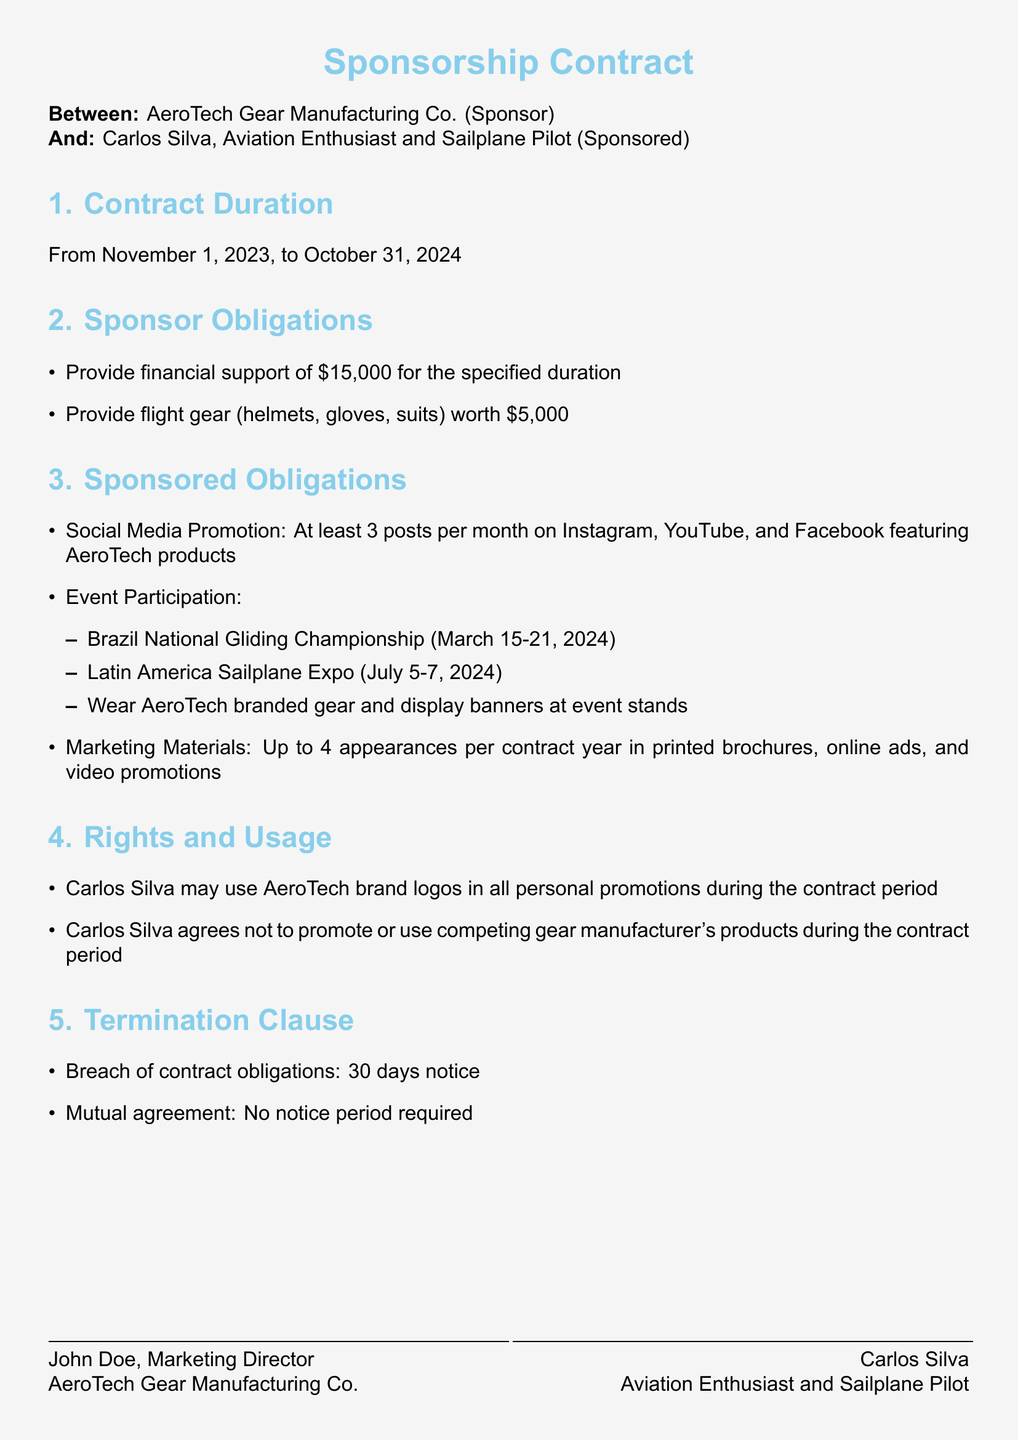What is the duration of the contract? The contract duration is specified in section 1 of the document, lasting from November 1, 2023, to October 31, 2024.
Answer: November 1, 2023, to October 31, 2024 How much financial support will the sponsor provide? The financial support amount is outlined in section 2 of the document, specifically listed as $15,000.
Answer: $15,000 What events is the sponsored required to participate in? The events are detailed under sponsored obligations in section 3, including the Brazil National Gliding Championship and Latin America Sailplane Expo.
Answer: Brazil National Gliding Championship, Latin America Sailplane Expo How many social media posts must the sponsored make per month? This requirement is listed in section 3 under social media promotion, which states at least 3 posts per month are mandatory.
Answer: 3 posts What rights does Carlos Silva have regarding using AeroTech brand logos? The rights section specifies that Carlos Silva may use AeroTech brand logos in all personal promotions during the contract period.
Answer: Use in personal promotions What is the termination notice period for breach of contract obligations? The termination clause in section 5 specifies a notice period of 30 days for breach of contract obligations.
Answer: 30 days Is Carlos Silva allowed to promote competing gear products during the contract period? The rights and usage section explicitly states that Carlos Silva agrees not to promote or use competing gear manufacturer's products.
Answer: No What is the total value of flight gear provided by the sponsor? The value of the flight gear is stated in section 2 as worth $5,000.
Answer: $5,000 